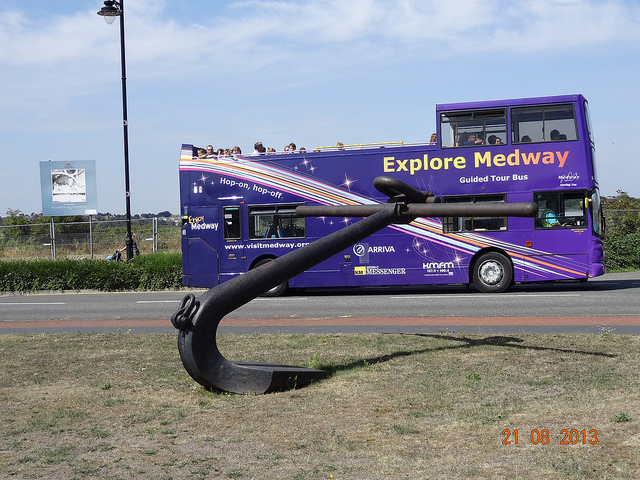<image>What brand of bus is this? The brand of the bus is unknown. It could be 'explore medway', 'arriva', or 'medway'. What brand of bus is this? I am not sure what brand of bus this is. It can be either 'explore medway' or 'arriva'. 